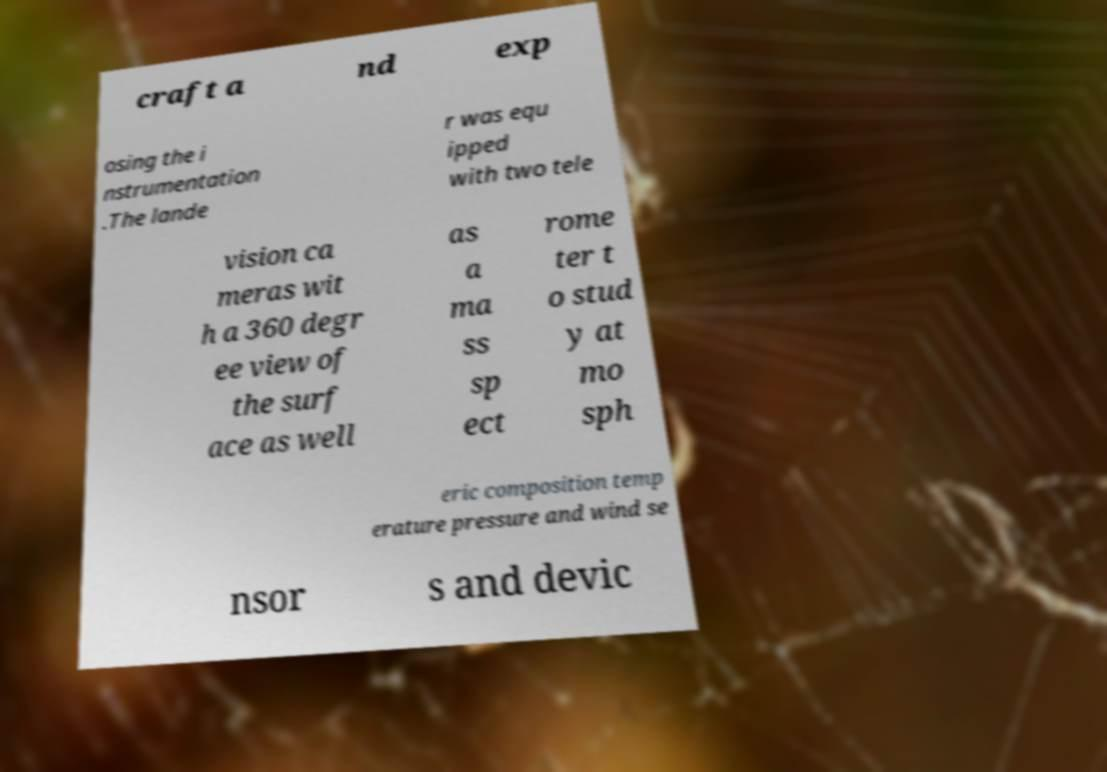For documentation purposes, I need the text within this image transcribed. Could you provide that? craft a nd exp osing the i nstrumentation .The lande r was equ ipped with two tele vision ca meras wit h a 360 degr ee view of the surf ace as well as a ma ss sp ect rome ter t o stud y at mo sph eric composition temp erature pressure and wind se nsor s and devic 